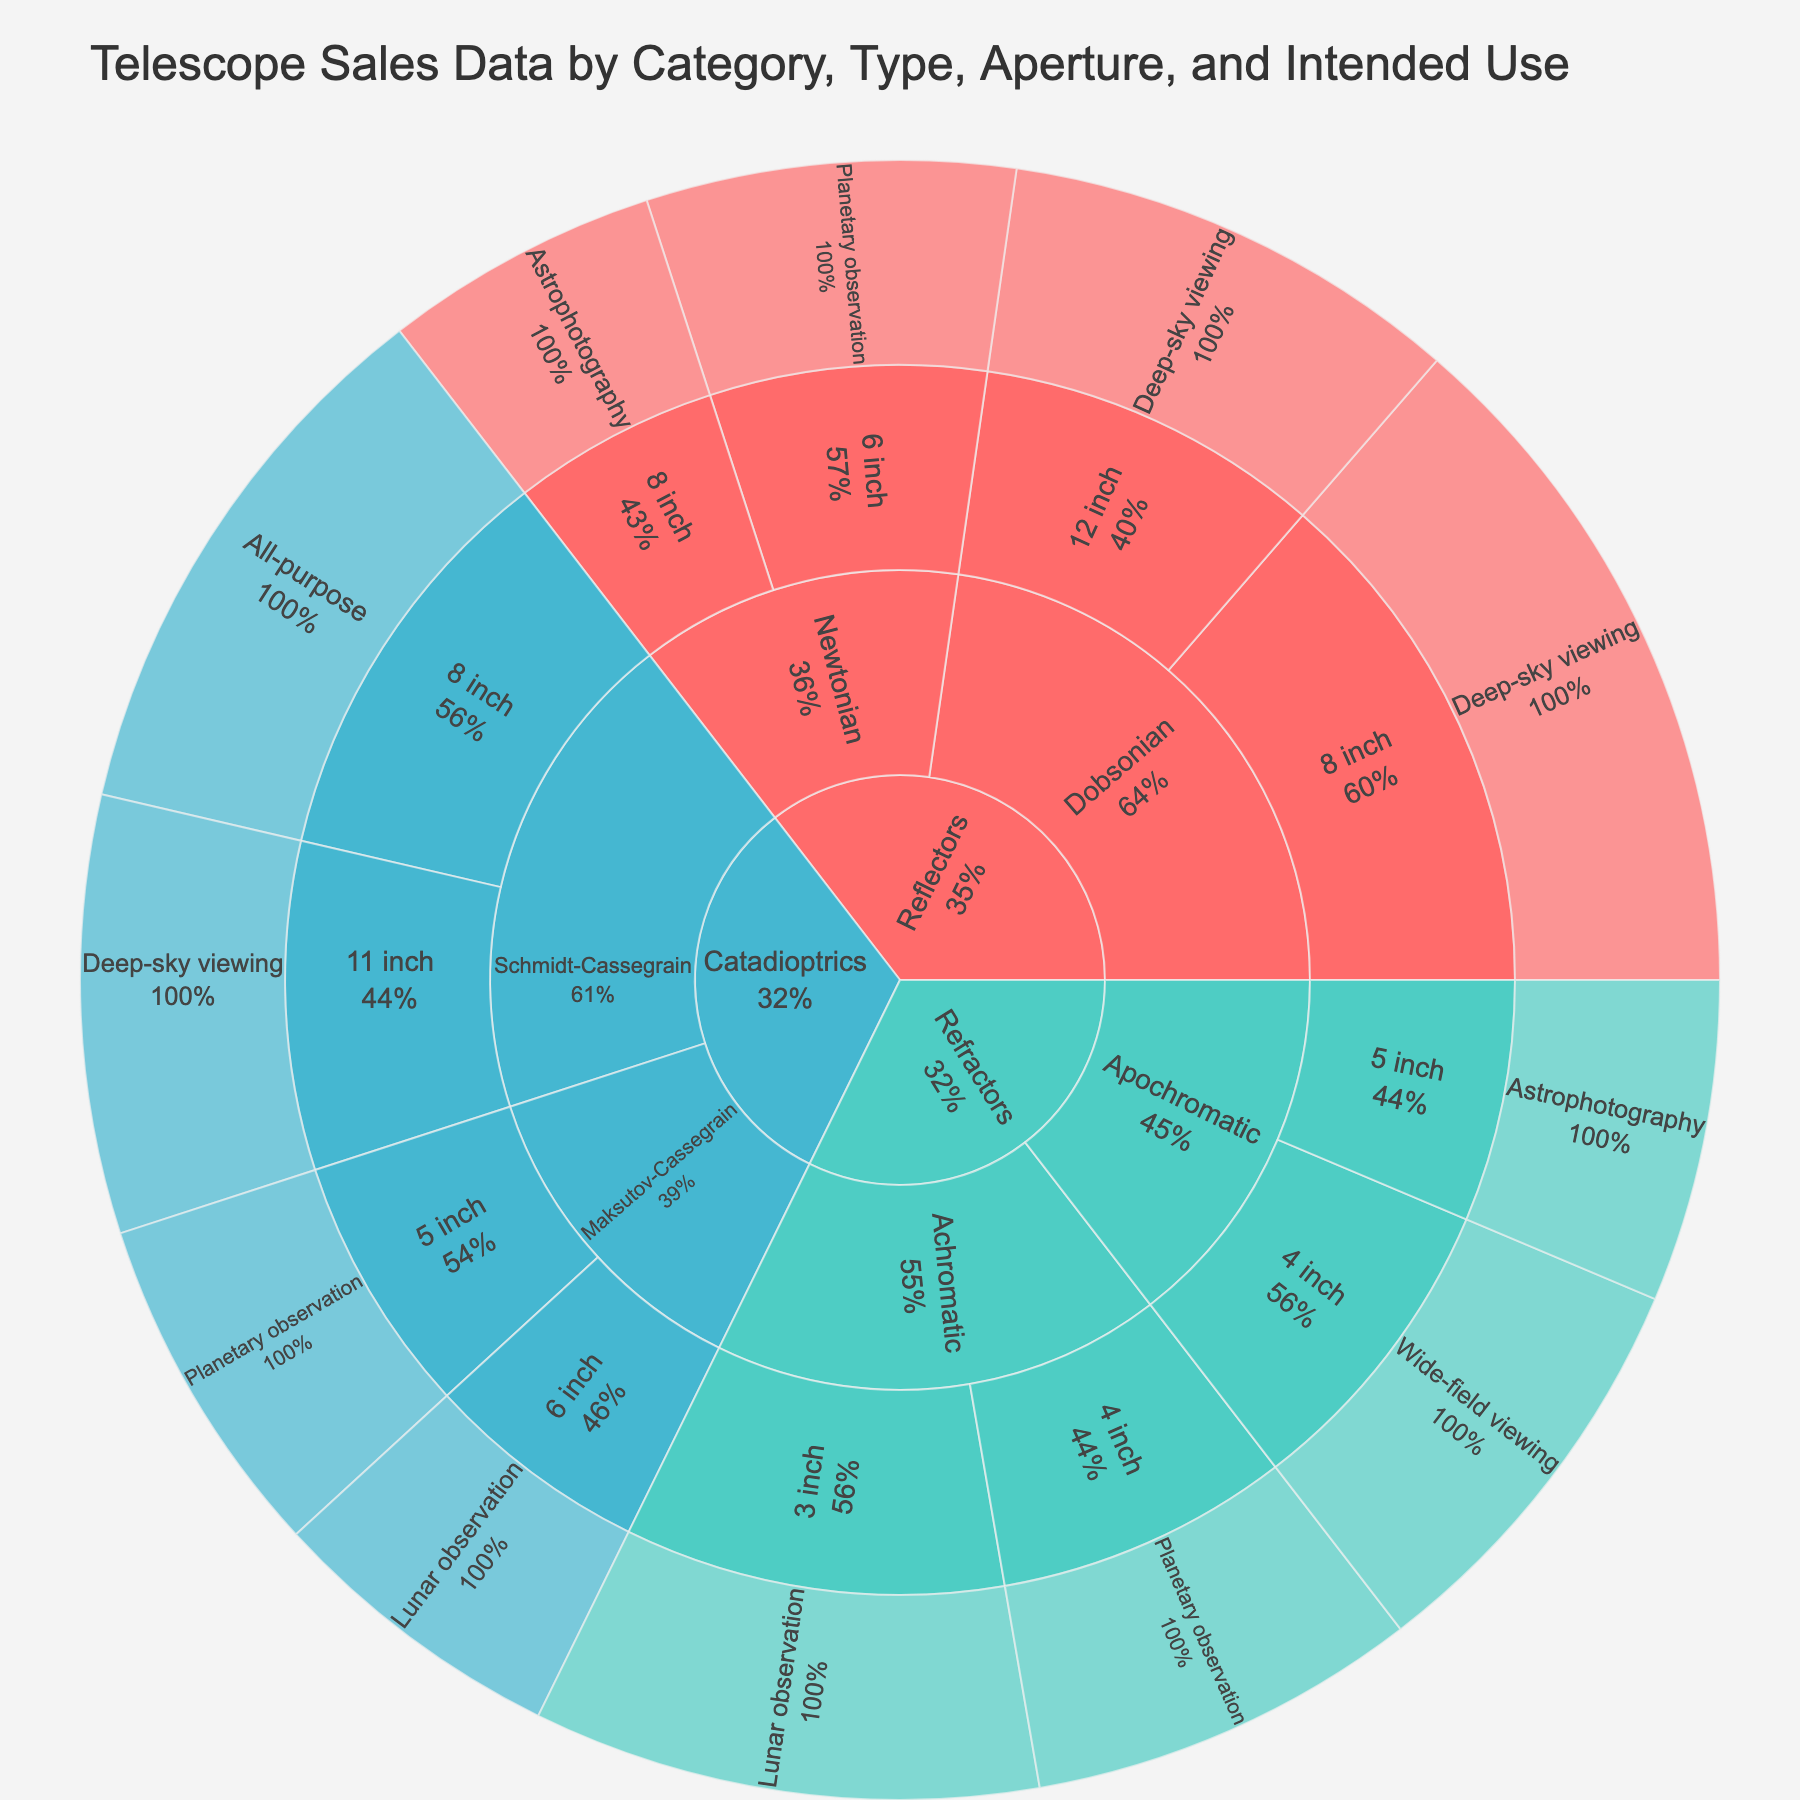What is the title of this sunburst plot? The title of the plot is usually prominently displayed at the top of the figure. Reading it provides the first piece of insight into what the plot is depicting.
Answer: Telescope Sales Data by Category, Type, Aperture, and Intended Use Which category has the highest sales value? In a sunburst plot, the outer segments represent subcategories of their parents. By looking at the outermost rings and their relative sizes or percentages, you can identify the category with the highest value.
Answer: Reflectors What is the total sales value for Refractors? To find the total sales value for Refractors, you sum up the values of all subcategories within the Refractors segment. These values are displayed within the Refractor section of the sunburst plot.
Answer: 355 Which type of telescope within the Reflectors category has the largest sales value? By focusing on the Reflectors segment and looking at the size and labels of its inner segments, one can determine which type, such as Dobsonian or Newtonian, has the largest sales.
Answer: Dobsonian How does the sales value of 8 inch Dobsonian compare to 12 inch Dobsonian? Look within the Dobsonian segment of Reflectors category and compare the sizes or percentages of the 8 inch and 12 inch subsegments.
Answer: The 8 inch has a higher value than the 12 inch Which intended use has the highest sales value within Schmidt-Cassegrain telescopes? By examining the subsegments of the Schmidt-Cassegrain section in the Catadioptrics category and comparing their sizes or values, one can determine the most popular intended use.
Answer: All-purpose What is the aggregate sales value for planetary observation across all categories and types? To calculate this, you'd sum the values of all the segments labeled 'Planetary observation' within the plot, regardless of their category or type parent segment.
Answer: 240 What is the difference in sales value between Apochromatic and Achromatic refractors? Find the total sales values by summing the subsegment values for both Apochromatic and Achromatic under the Refractors category, then compute the difference.
Answer: 95 Which category and type combination has the lowest sales value? By examining the size and labels of each segment within the sunburst plot, you can identify the category and type combination with the smallest segment.
Answer: Maksutov-Cassegrain within Catadioptrics If the sales value for Newtonian Reflectors increased by 20%, what would the new value be? Calculate 20% of the current total sales value for Newtonian Reflectors by summing up its subsegments, and then add this amount to the current total to get the new value.
Answer: 168 